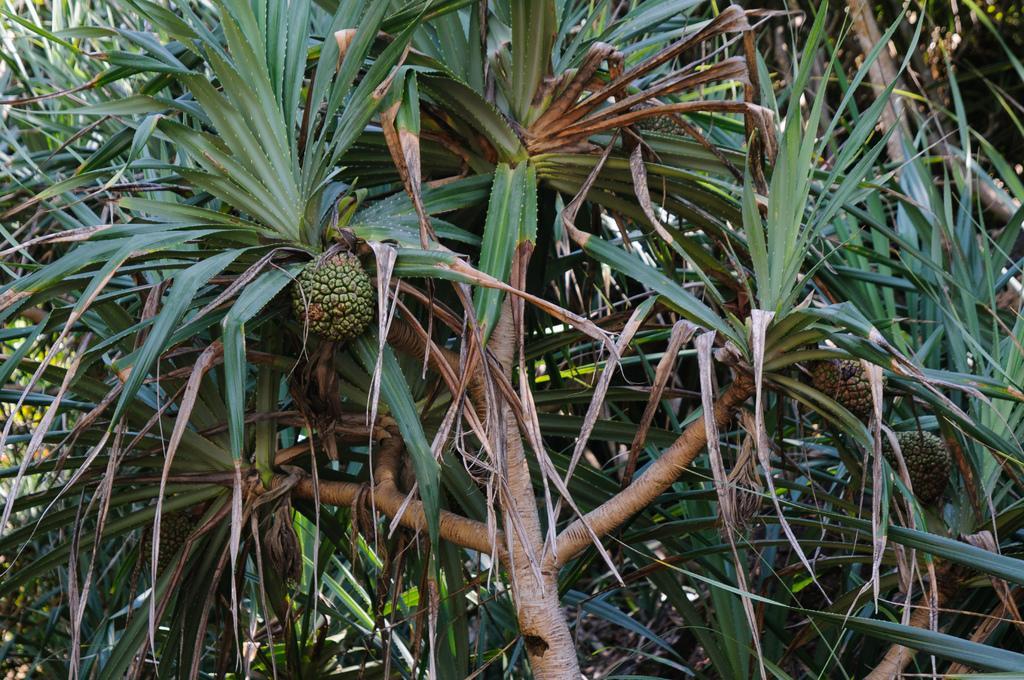In one or two sentences, can you explain what this image depicts? In the image we can see some trees, on the trees there are some fruits. 